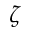<formula> <loc_0><loc_0><loc_500><loc_500>\zeta</formula> 